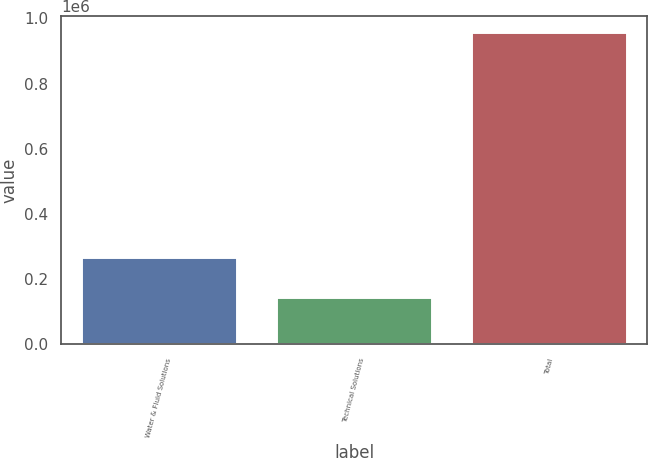Convert chart to OTSL. <chart><loc_0><loc_0><loc_500><loc_500><bar_chart><fcel>Water & Fluid Solutions<fcel>Technical Solutions<fcel>Total<nl><fcel>268599<fcel>144154<fcel>959460<nl></chart> 